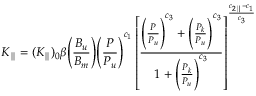Convert formula to latex. <formula><loc_0><loc_0><loc_500><loc_500>K _ { \| } = ( K _ { \| } ) _ { 0 } \beta \left ( \frac { B _ { u } } { B _ { m } } \right ) \left ( \frac { P } { P _ { u } } \right ) ^ { c _ { 1 } } \left [ \frac { \left ( \frac { P } { P _ { u } } \right ) ^ { c _ { 3 } } + \left ( \frac { P _ { k } } { P _ { u } } \right ) ^ { c _ { 3 } } } { 1 + \left ( \frac { P _ { k } } { P _ { u } } \right ) ^ { c _ { 3 } } } \right ] ^ { \frac { c _ { 2 \| } - c _ { 1 } } { c _ { 3 } } }</formula> 